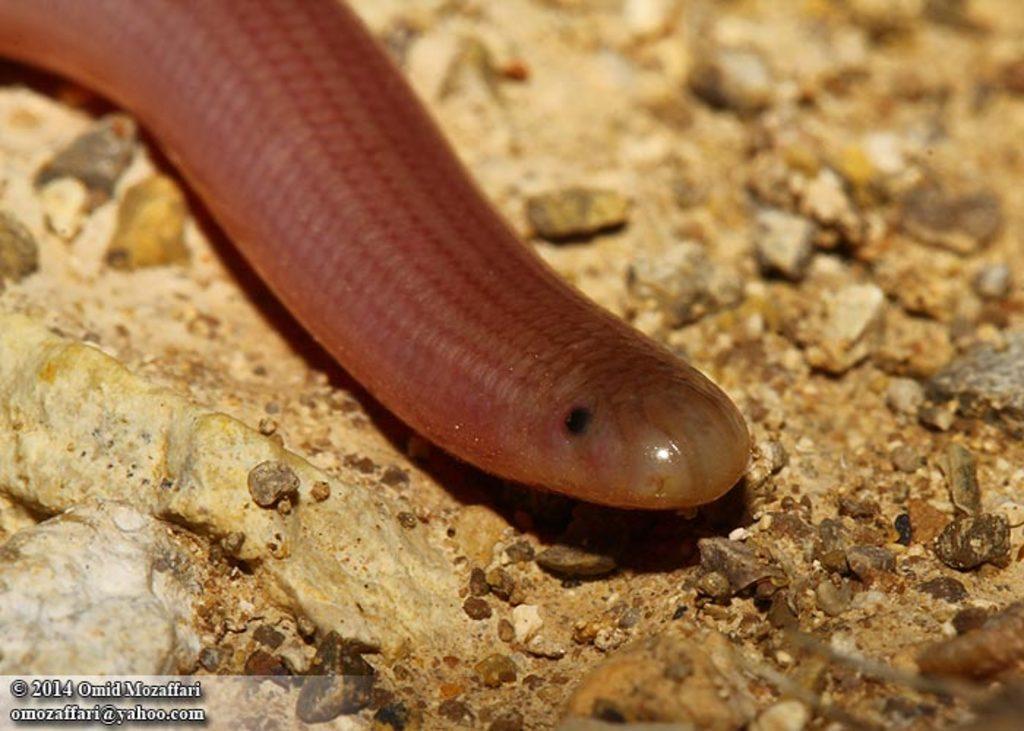Please provide a concise description of this image. This picture contains a slug which is brown in color. At the bottom of the picture, we see the rock and the small stones. 